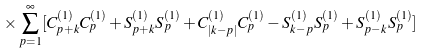<formula> <loc_0><loc_0><loc_500><loc_500>\times \sum _ { p = 1 } ^ { \infty } [ C _ { p + k } ^ { ( 1 ) } C _ { p } ^ { ( 1 ) } + S _ { p + k } ^ { ( 1 ) } S _ { p } ^ { ( 1 ) } + C _ { | k - p | } ^ { ( 1 ) } C _ { p } ^ { ( 1 ) } - S _ { k - p } ^ { ( 1 ) } S _ { p } ^ { ( 1 ) } + S _ { p - k } ^ { ( 1 ) } S _ { p } ^ { ( 1 ) } ]</formula> 